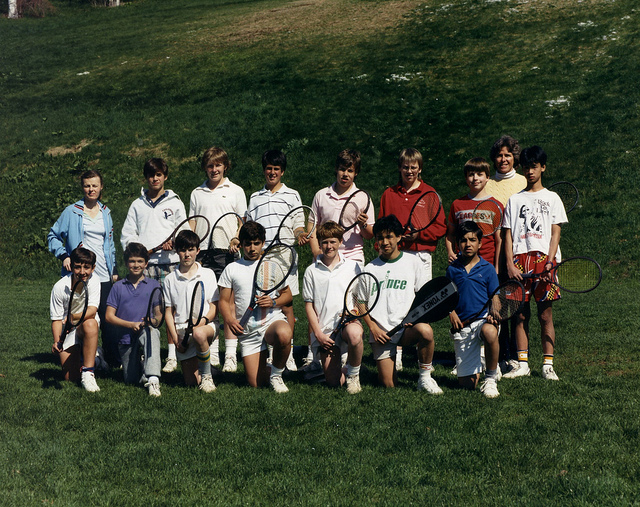Read all the text in this image. prince 